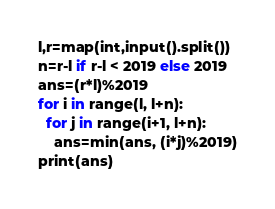Convert code to text. <code><loc_0><loc_0><loc_500><loc_500><_Python_>l,r=map(int,input().split())
n=r-l if r-l < 2019 else 2019
ans=(r*l)%2019
for i in range(l, l+n):
  for j in range(i+1, l+n):
    ans=min(ans, (i*j)%2019)
print(ans)</code> 